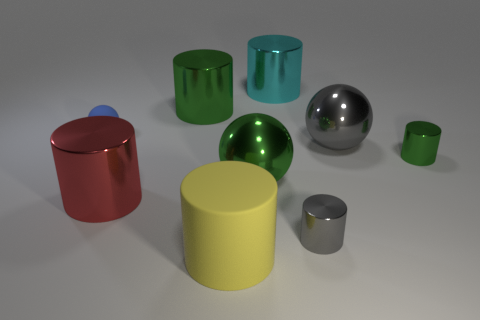How many metallic things are either cylinders or big green cylinders?
Provide a succinct answer. 5. What size is the shiny object that is behind the red object and in front of the small green cylinder?
Your response must be concise. Large. Are there any gray shiny balls that are behind the green shiny object to the left of the green sphere?
Ensure brevity in your answer.  No. What number of large metallic cylinders are right of the red metallic thing?
Your response must be concise. 2. What color is the other matte object that is the same shape as the red object?
Provide a succinct answer. Yellow. Is the big green object that is left of the rubber cylinder made of the same material as the green cylinder that is in front of the small blue rubber ball?
Offer a very short reply. Yes. There is a rubber sphere; is its color the same as the large metal cylinder on the right side of the yellow matte cylinder?
Your answer should be compact. No. What shape is the tiny object that is left of the tiny green shiny cylinder and behind the large green sphere?
Your response must be concise. Sphere. How many large rubber objects are there?
Your answer should be compact. 1. What is the size of the yellow thing that is the same shape as the large cyan thing?
Offer a terse response. Large. 